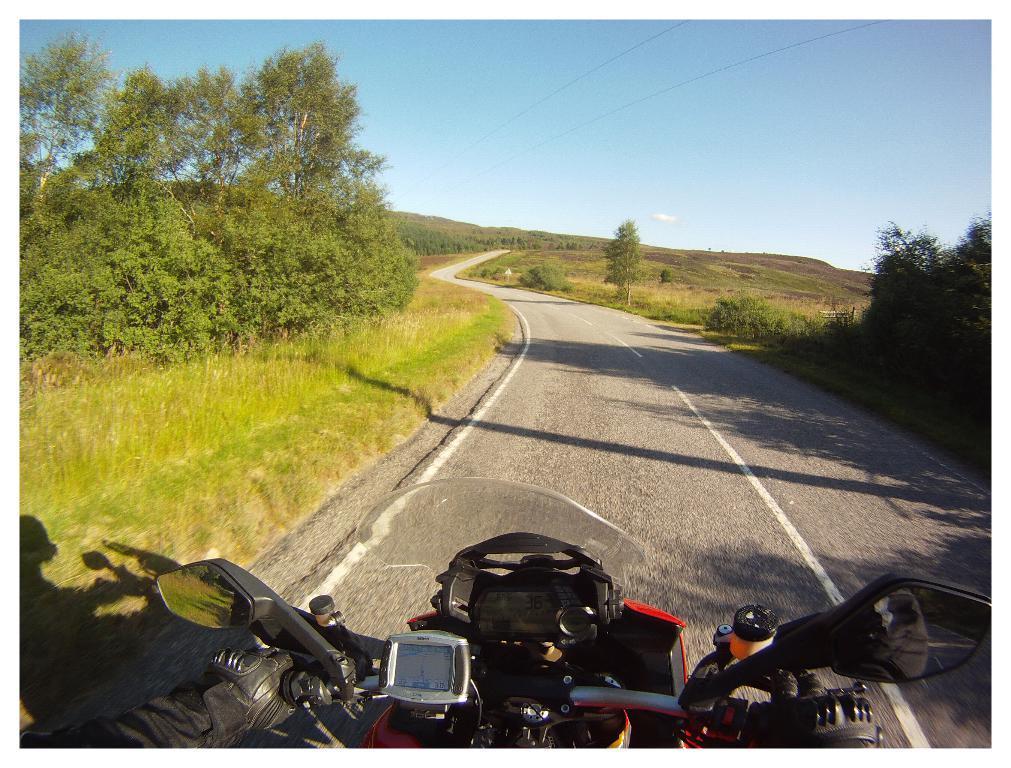In one or two sentences, can you explain what this image depicts? In this image I can see a road in the centre and on it I can see a vehicle. I can also see hands of a person and I can see this person is wearing gloves. On the both side of the road I can see grass and number of trees. In the background I can see the sky and wires. 